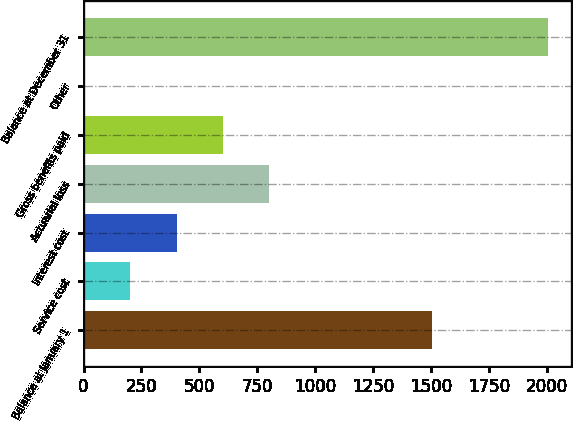Convert chart to OTSL. <chart><loc_0><loc_0><loc_500><loc_500><bar_chart><fcel>Balance at January 1<fcel>Service cost<fcel>Interest cost<fcel>Actuarial loss<fcel>Gross benefits paid<fcel>Other<fcel>Balance at December 31<nl><fcel>1505<fcel>201.5<fcel>402<fcel>803<fcel>602.5<fcel>1<fcel>2006<nl></chart> 